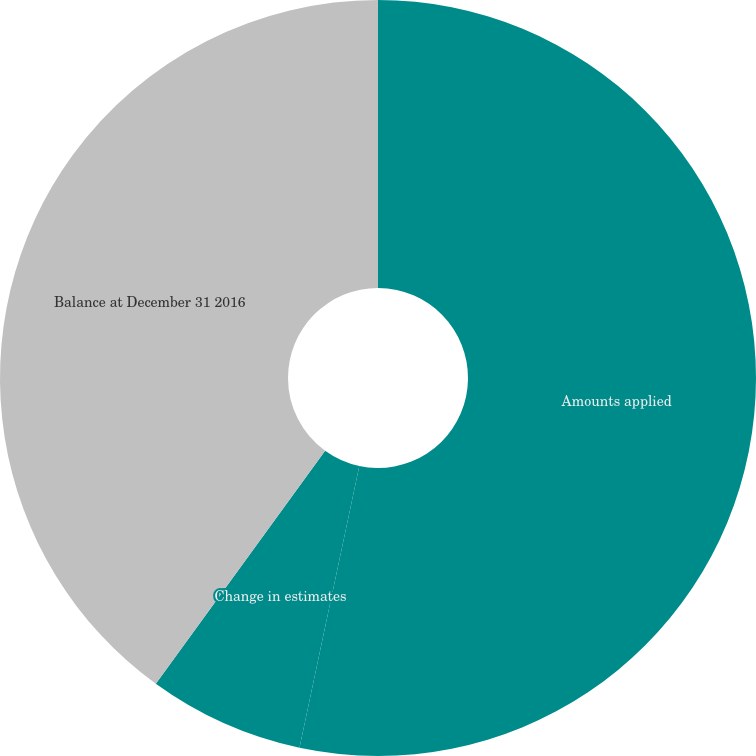Convert chart to OTSL. <chart><loc_0><loc_0><loc_500><loc_500><pie_chart><fcel>Amounts applied<fcel>Change in estimates<fcel>Balance at December 31 2016<nl><fcel>53.33%<fcel>6.67%<fcel>40.0%<nl></chart> 